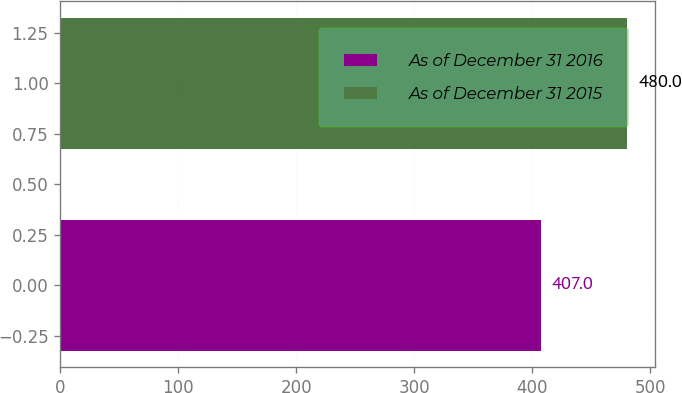<chart> <loc_0><loc_0><loc_500><loc_500><bar_chart><fcel>As of December 31 2016<fcel>As of December 31 2015<nl><fcel>407<fcel>480<nl></chart> 